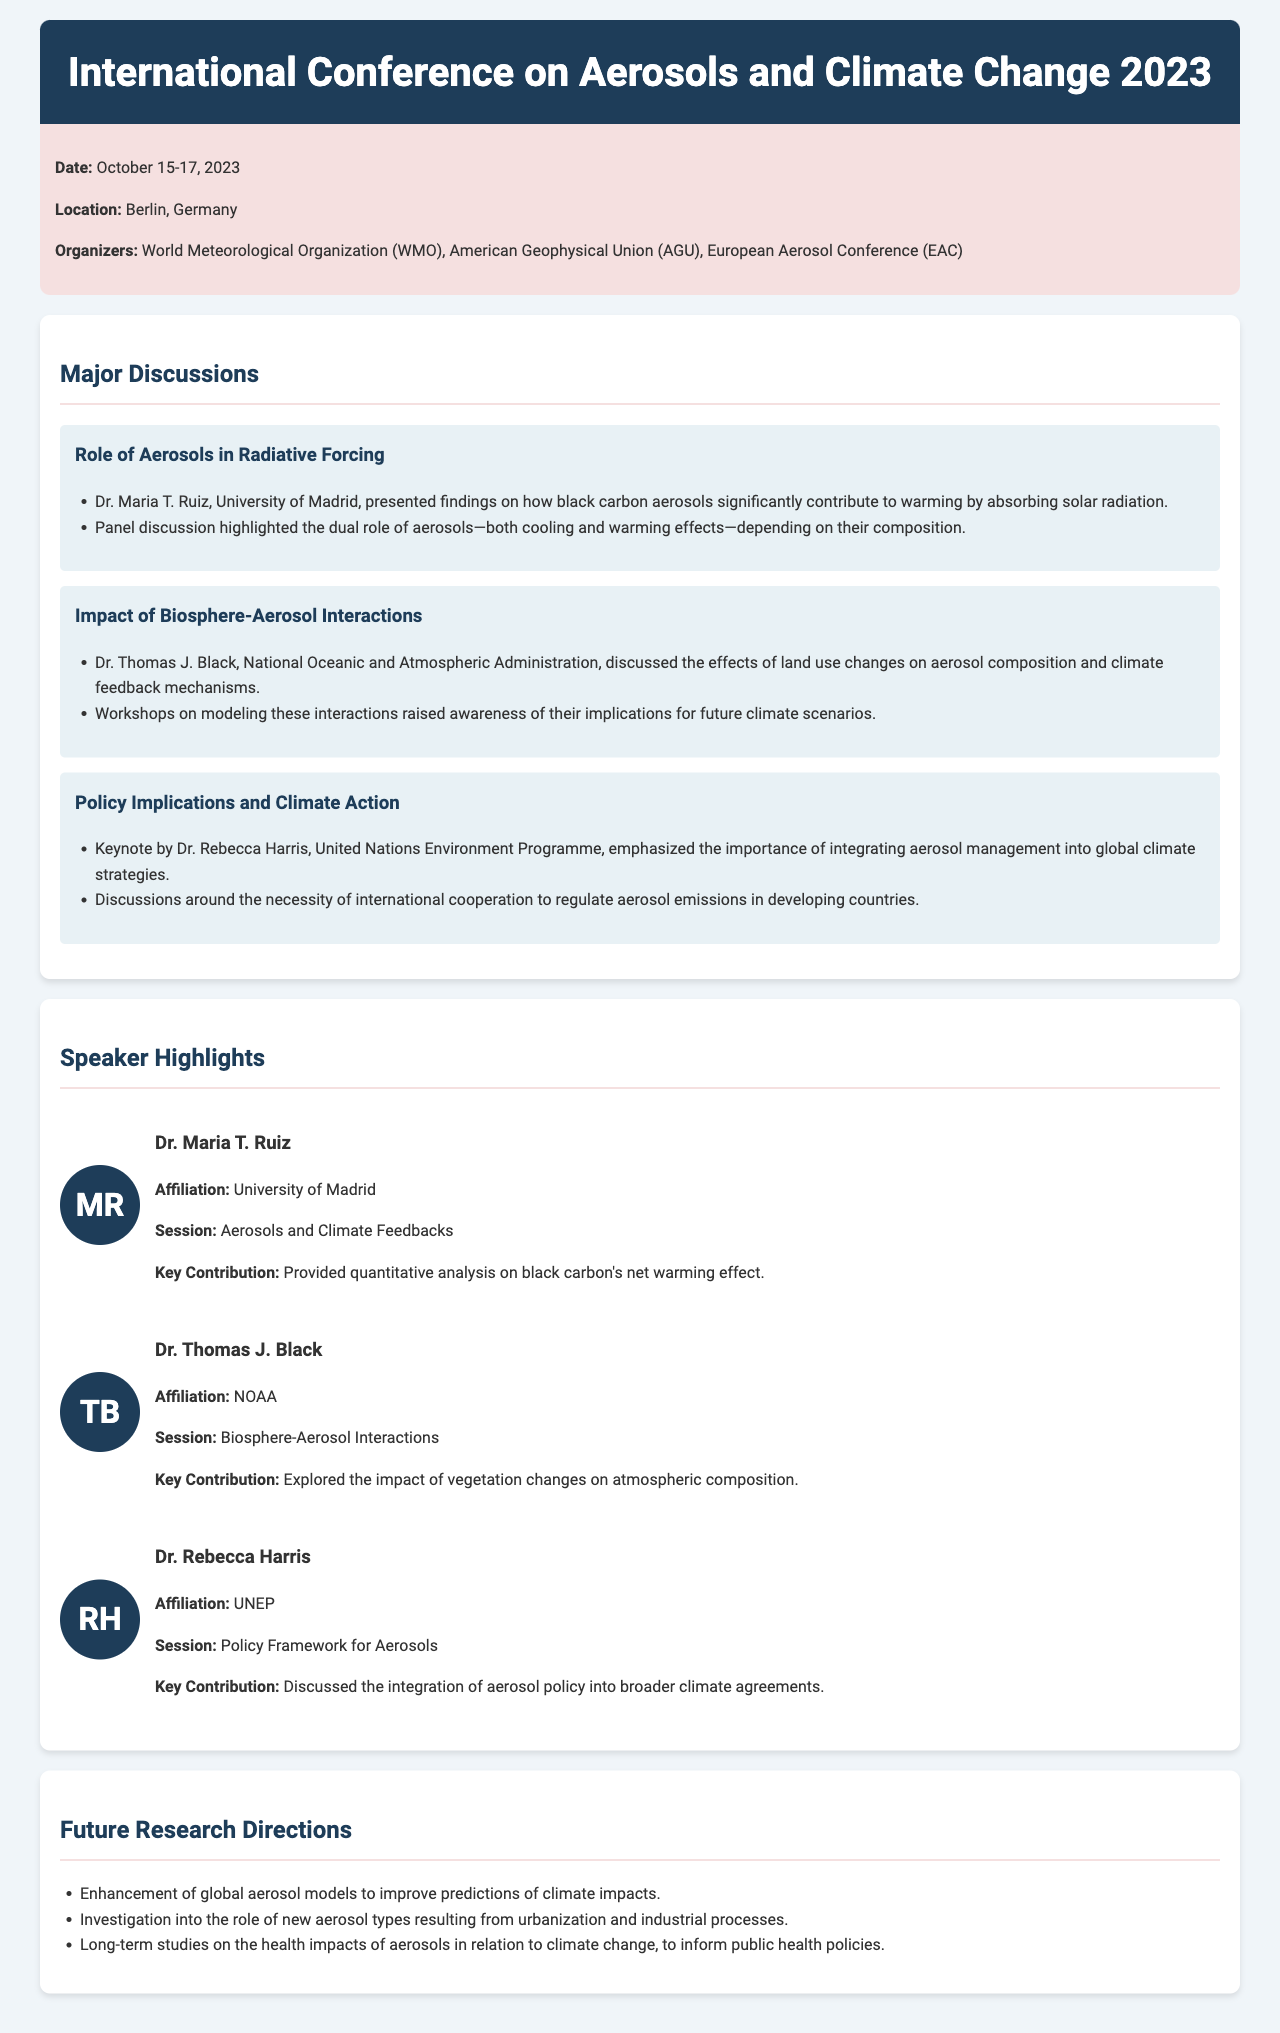What were the dates of the conference? The document specifies that the conference took place from October 15-17, 2023.
Answer: October 15-17, 2023 Who organized the conference? The conference was organized by the World Meteorological Organization, American Geophysical Union, and European Aerosol Conference.
Answer: WMO, AGU, EAC What was Dr. Maria T. Ruiz's key contribution? The document states that Dr. Maria T. Ruiz provided a quantitative analysis on black carbon's net warming effect.
Answer: Quantitative analysis on black carbon's net warming effect What is one of the future research directions mentioned? The document lists enhancement of global aerosol models as one of the future research directions.
Answer: Enhancement of global aerosol models Who emphasized the importance of integrating aerosol management into global climate strategies? Dr. Rebecca Harris emphasized the importance of integrating aerosol management into climate strategies during her keynote.
Answer: Dr. Rebecca Harris What background color is used for the conference info section? The conference info section has a background color of #f5e0e0.
Answer: #f5e0e0 What was discussed in relation to land use changes? Dr. Thomas J. Black discussed the effects of land use changes on aerosol composition and climate feedback mechanisms.
Answer: Effects of land use changes on aerosol composition What is the location of the conference? The location of the conference is specified in the document as Berlin, Germany.
Answer: Berlin, Germany 